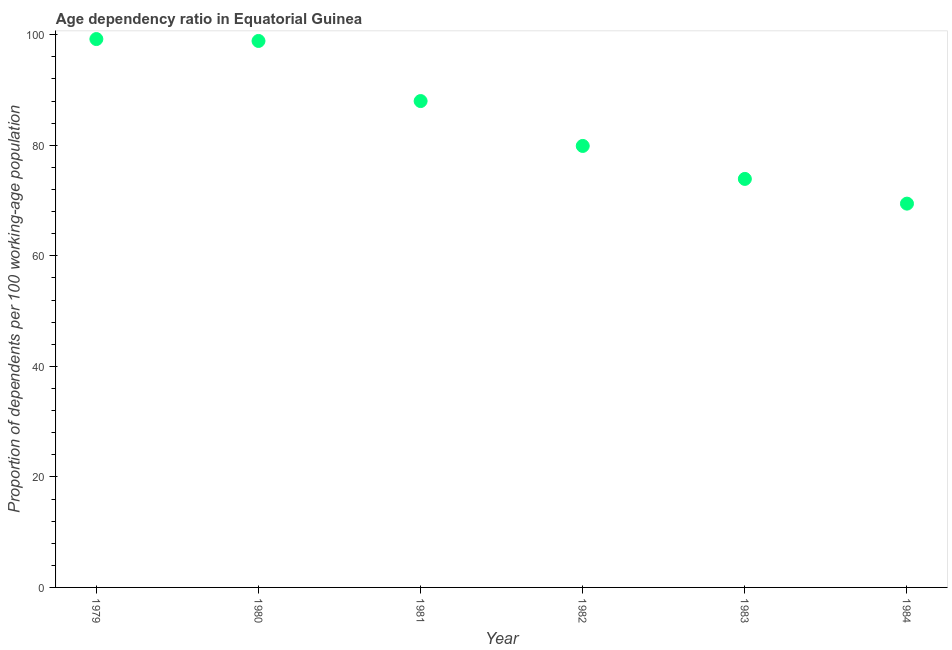What is the age dependency ratio in 1983?
Provide a succinct answer. 73.92. Across all years, what is the maximum age dependency ratio?
Offer a terse response. 99.23. Across all years, what is the minimum age dependency ratio?
Your answer should be compact. 69.45. In which year was the age dependency ratio maximum?
Provide a short and direct response. 1979. What is the sum of the age dependency ratio?
Provide a short and direct response. 509.36. What is the difference between the age dependency ratio in 1981 and 1983?
Offer a terse response. 14.09. What is the average age dependency ratio per year?
Offer a very short reply. 84.89. What is the median age dependency ratio?
Your answer should be compact. 83.94. Do a majority of the years between 1983 and 1982 (inclusive) have age dependency ratio greater than 28 ?
Your answer should be very brief. No. What is the ratio of the age dependency ratio in 1981 to that in 1984?
Your response must be concise. 1.27. Is the difference between the age dependency ratio in 1980 and 1981 greater than the difference between any two years?
Provide a succinct answer. No. What is the difference between the highest and the second highest age dependency ratio?
Make the answer very short. 0.34. What is the difference between the highest and the lowest age dependency ratio?
Ensure brevity in your answer.  29.78. In how many years, is the age dependency ratio greater than the average age dependency ratio taken over all years?
Your answer should be very brief. 3. How many years are there in the graph?
Offer a terse response. 6. What is the difference between two consecutive major ticks on the Y-axis?
Offer a terse response. 20. Are the values on the major ticks of Y-axis written in scientific E-notation?
Keep it short and to the point. No. Does the graph contain any zero values?
Provide a short and direct response. No. What is the title of the graph?
Your answer should be very brief. Age dependency ratio in Equatorial Guinea. What is the label or title of the X-axis?
Make the answer very short. Year. What is the label or title of the Y-axis?
Your answer should be very brief. Proportion of dependents per 100 working-age population. What is the Proportion of dependents per 100 working-age population in 1979?
Your response must be concise. 99.23. What is the Proportion of dependents per 100 working-age population in 1980?
Ensure brevity in your answer.  98.88. What is the Proportion of dependents per 100 working-age population in 1981?
Give a very brief answer. 88. What is the Proportion of dependents per 100 working-age population in 1982?
Keep it short and to the point. 79.88. What is the Proportion of dependents per 100 working-age population in 1983?
Give a very brief answer. 73.92. What is the Proportion of dependents per 100 working-age population in 1984?
Offer a terse response. 69.45. What is the difference between the Proportion of dependents per 100 working-age population in 1979 and 1980?
Make the answer very short. 0.34. What is the difference between the Proportion of dependents per 100 working-age population in 1979 and 1981?
Give a very brief answer. 11.22. What is the difference between the Proportion of dependents per 100 working-age population in 1979 and 1982?
Ensure brevity in your answer.  19.34. What is the difference between the Proportion of dependents per 100 working-age population in 1979 and 1983?
Your answer should be very brief. 25.31. What is the difference between the Proportion of dependents per 100 working-age population in 1979 and 1984?
Make the answer very short. 29.78. What is the difference between the Proportion of dependents per 100 working-age population in 1980 and 1981?
Ensure brevity in your answer.  10.88. What is the difference between the Proportion of dependents per 100 working-age population in 1980 and 1982?
Ensure brevity in your answer.  19. What is the difference between the Proportion of dependents per 100 working-age population in 1980 and 1983?
Make the answer very short. 24.96. What is the difference between the Proportion of dependents per 100 working-age population in 1980 and 1984?
Ensure brevity in your answer.  29.44. What is the difference between the Proportion of dependents per 100 working-age population in 1981 and 1982?
Make the answer very short. 8.12. What is the difference between the Proportion of dependents per 100 working-age population in 1981 and 1983?
Provide a succinct answer. 14.09. What is the difference between the Proportion of dependents per 100 working-age population in 1981 and 1984?
Provide a succinct answer. 18.56. What is the difference between the Proportion of dependents per 100 working-age population in 1982 and 1983?
Your answer should be compact. 5.97. What is the difference between the Proportion of dependents per 100 working-age population in 1982 and 1984?
Make the answer very short. 10.44. What is the difference between the Proportion of dependents per 100 working-age population in 1983 and 1984?
Provide a short and direct response. 4.47. What is the ratio of the Proportion of dependents per 100 working-age population in 1979 to that in 1980?
Ensure brevity in your answer.  1. What is the ratio of the Proportion of dependents per 100 working-age population in 1979 to that in 1981?
Keep it short and to the point. 1.13. What is the ratio of the Proportion of dependents per 100 working-age population in 1979 to that in 1982?
Provide a short and direct response. 1.24. What is the ratio of the Proportion of dependents per 100 working-age population in 1979 to that in 1983?
Provide a short and direct response. 1.34. What is the ratio of the Proportion of dependents per 100 working-age population in 1979 to that in 1984?
Provide a short and direct response. 1.43. What is the ratio of the Proportion of dependents per 100 working-age population in 1980 to that in 1981?
Provide a short and direct response. 1.12. What is the ratio of the Proportion of dependents per 100 working-age population in 1980 to that in 1982?
Ensure brevity in your answer.  1.24. What is the ratio of the Proportion of dependents per 100 working-age population in 1980 to that in 1983?
Ensure brevity in your answer.  1.34. What is the ratio of the Proportion of dependents per 100 working-age population in 1980 to that in 1984?
Your answer should be compact. 1.42. What is the ratio of the Proportion of dependents per 100 working-age population in 1981 to that in 1982?
Give a very brief answer. 1.1. What is the ratio of the Proportion of dependents per 100 working-age population in 1981 to that in 1983?
Offer a very short reply. 1.19. What is the ratio of the Proportion of dependents per 100 working-age population in 1981 to that in 1984?
Make the answer very short. 1.27. What is the ratio of the Proportion of dependents per 100 working-age population in 1982 to that in 1983?
Offer a very short reply. 1.08. What is the ratio of the Proportion of dependents per 100 working-age population in 1982 to that in 1984?
Give a very brief answer. 1.15. What is the ratio of the Proportion of dependents per 100 working-age population in 1983 to that in 1984?
Your response must be concise. 1.06. 